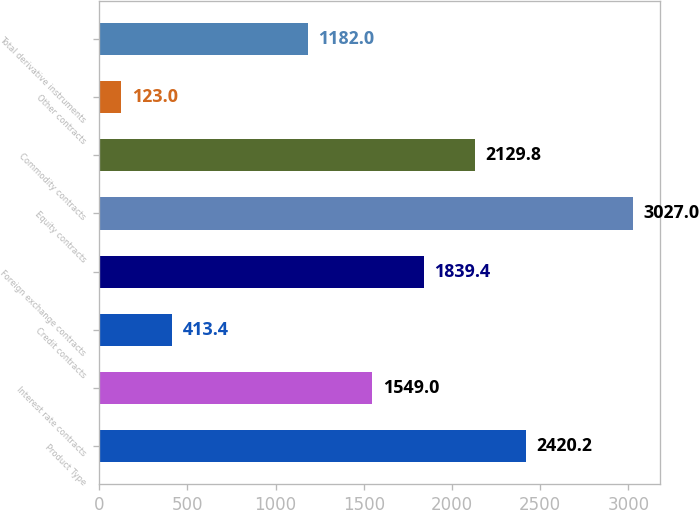Convert chart. <chart><loc_0><loc_0><loc_500><loc_500><bar_chart><fcel>Product Type<fcel>Interest rate contracts<fcel>Credit contracts<fcel>Foreign exchange contracts<fcel>Equity contracts<fcel>Commodity contracts<fcel>Other contracts<fcel>Total derivative instruments<nl><fcel>2420.2<fcel>1549<fcel>413.4<fcel>1839.4<fcel>3027<fcel>2129.8<fcel>123<fcel>1182<nl></chart> 